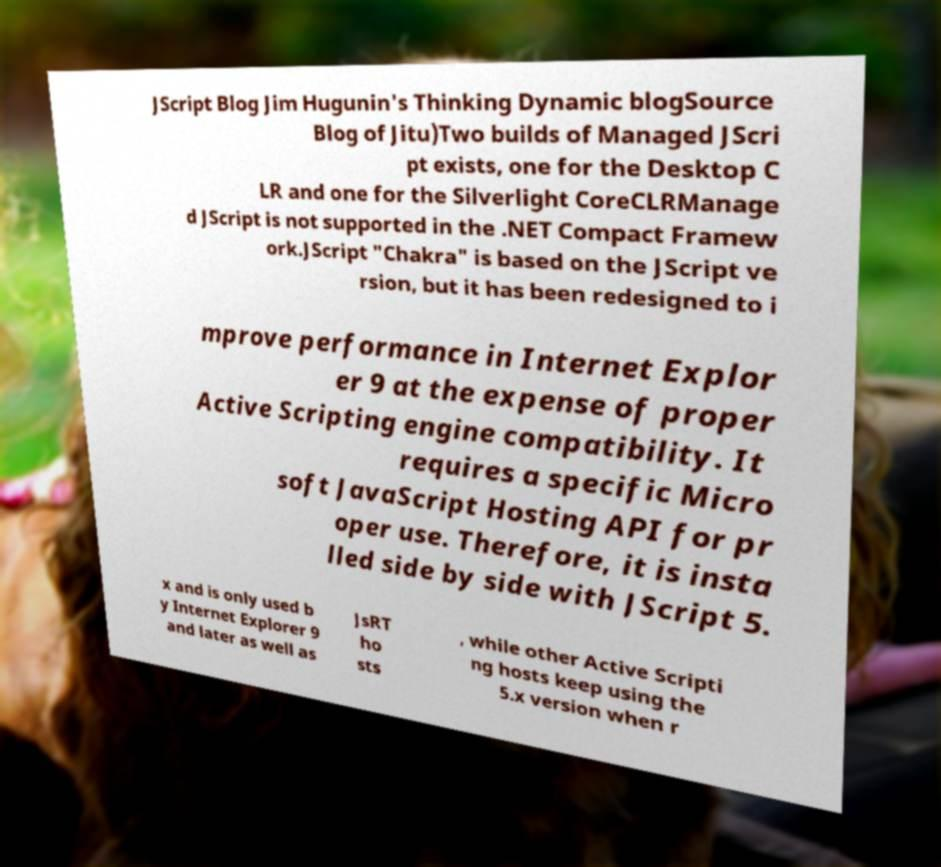For documentation purposes, I need the text within this image transcribed. Could you provide that? JScript Blog Jim Hugunin's Thinking Dynamic blogSource Blog of Jitu)Two builds of Managed JScri pt exists, one for the Desktop C LR and one for the Silverlight CoreCLRManage d JScript is not supported in the .NET Compact Framew ork.JScript "Chakra" is based on the JScript ve rsion, but it has been redesigned to i mprove performance in Internet Explor er 9 at the expense of proper Active Scripting engine compatibility. It requires a specific Micro soft JavaScript Hosting API for pr oper use. Therefore, it is insta lled side by side with JScript 5. x and is only used b y Internet Explorer 9 and later as well as JsRT ho sts , while other Active Scripti ng hosts keep using the 5.x version when r 